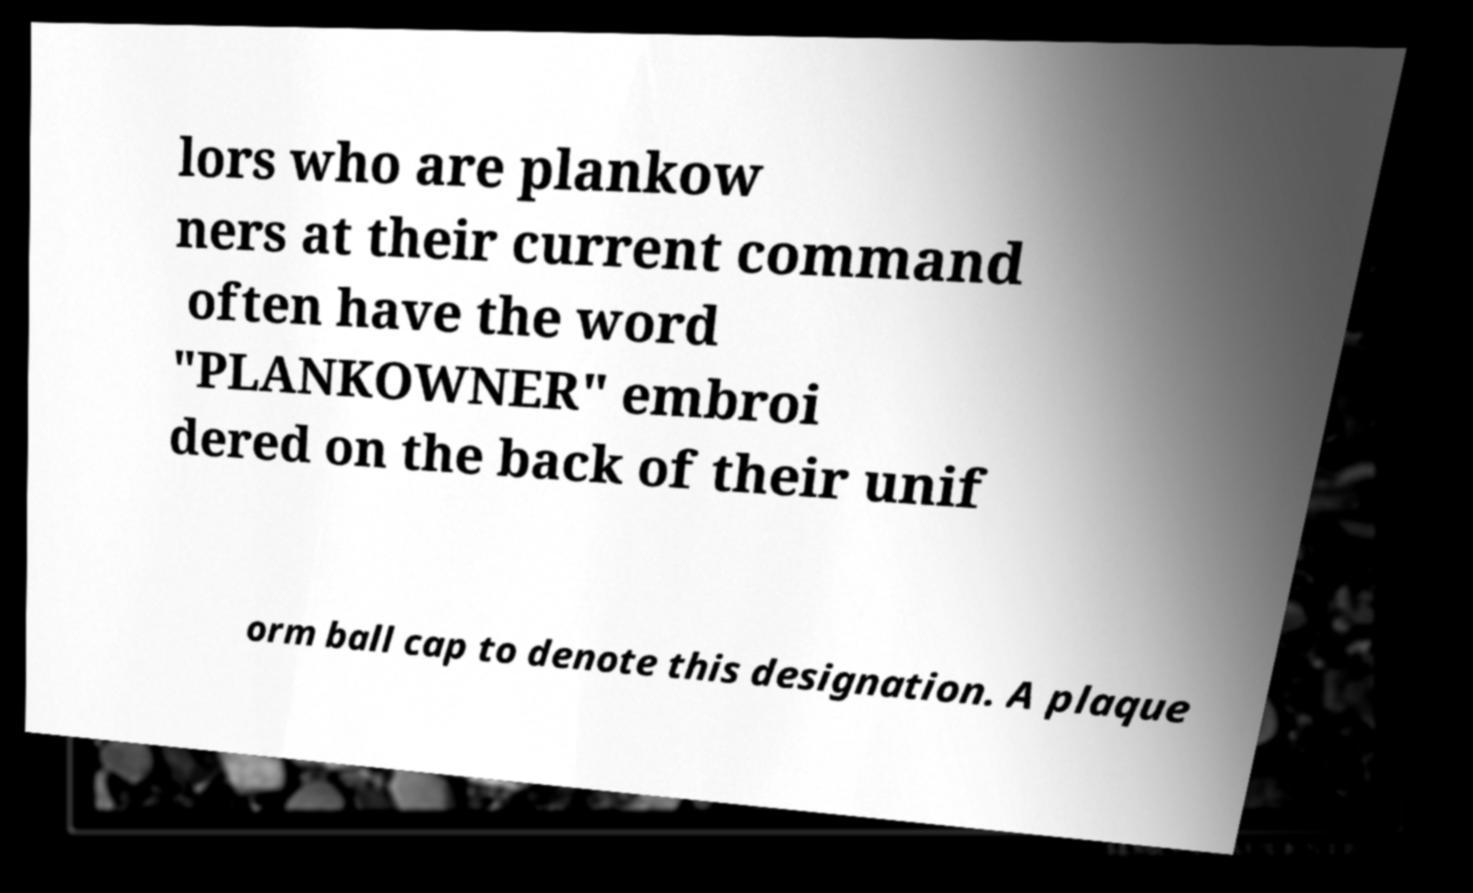Could you assist in decoding the text presented in this image and type it out clearly? lors who are plankow ners at their current command often have the word "PLANKOWNER" embroi dered on the back of their unif orm ball cap to denote this designation. A plaque 